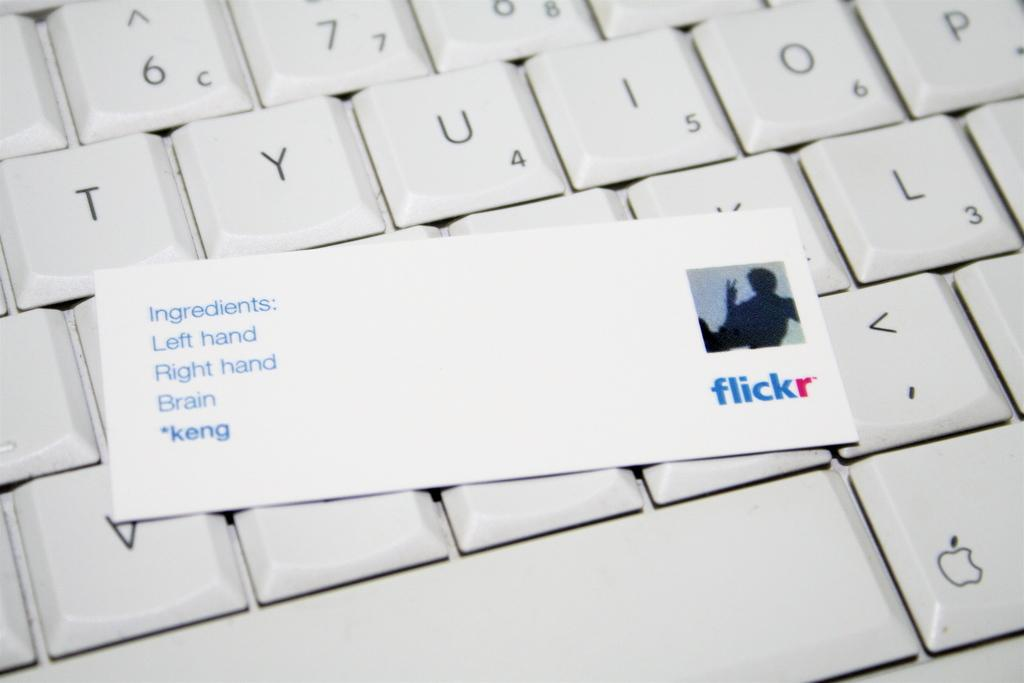<image>
Share a concise interpretation of the image provided. A card with the Flickr logo on it laying on top of a keyboard. 